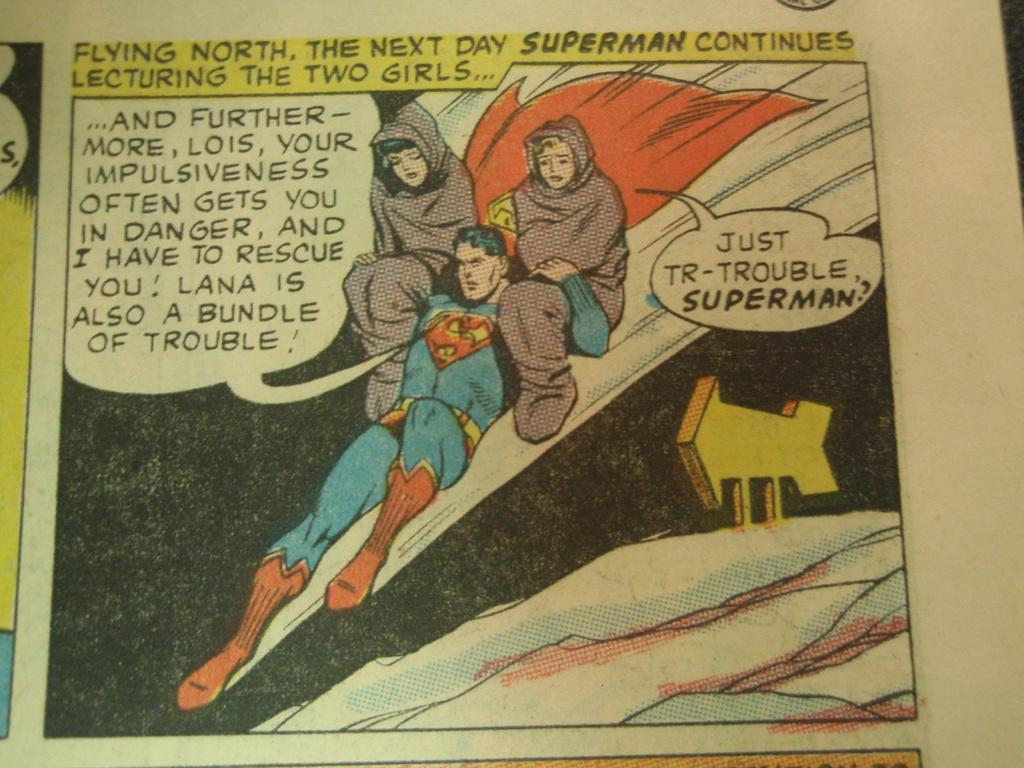<image>
Create a compact narrative representing the image presented. a comic that says 'flying north, the next day superman continues lecturing the two girls...' 